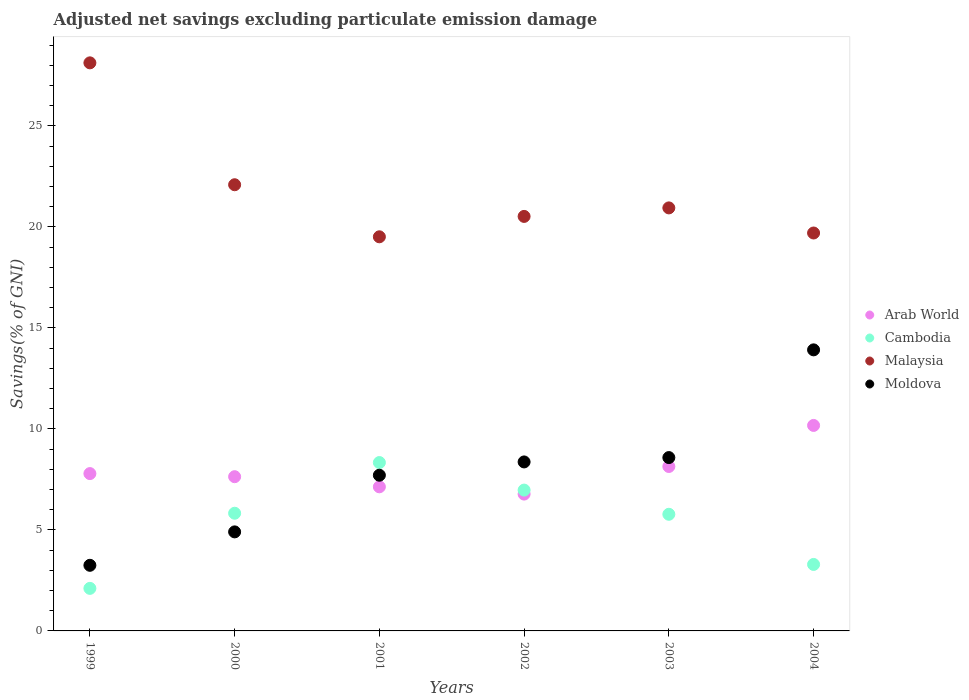How many different coloured dotlines are there?
Give a very brief answer. 4. Is the number of dotlines equal to the number of legend labels?
Your answer should be compact. Yes. What is the adjusted net savings in Malaysia in 2000?
Offer a terse response. 22.09. Across all years, what is the maximum adjusted net savings in Arab World?
Your answer should be compact. 10.17. Across all years, what is the minimum adjusted net savings in Cambodia?
Keep it short and to the point. 2.11. In which year was the adjusted net savings in Moldova maximum?
Make the answer very short. 2004. In which year was the adjusted net savings in Moldova minimum?
Make the answer very short. 1999. What is the total adjusted net savings in Moldova in the graph?
Offer a terse response. 46.72. What is the difference between the adjusted net savings in Cambodia in 2001 and that in 2004?
Ensure brevity in your answer.  5.04. What is the difference between the adjusted net savings in Arab World in 2004 and the adjusted net savings in Moldova in 2001?
Make the answer very short. 2.46. What is the average adjusted net savings in Malaysia per year?
Your response must be concise. 21.81. In the year 1999, what is the difference between the adjusted net savings in Arab World and adjusted net savings in Malaysia?
Provide a short and direct response. -20.33. In how many years, is the adjusted net savings in Malaysia greater than 1 %?
Give a very brief answer. 6. What is the ratio of the adjusted net savings in Arab World in 2001 to that in 2002?
Ensure brevity in your answer.  1.05. What is the difference between the highest and the second highest adjusted net savings in Cambodia?
Your response must be concise. 1.36. What is the difference between the highest and the lowest adjusted net savings in Arab World?
Make the answer very short. 3.4. In how many years, is the adjusted net savings in Cambodia greater than the average adjusted net savings in Cambodia taken over all years?
Your answer should be compact. 4. Is the sum of the adjusted net savings in Moldova in 2001 and 2003 greater than the maximum adjusted net savings in Arab World across all years?
Give a very brief answer. Yes. Is it the case that in every year, the sum of the adjusted net savings in Arab World and adjusted net savings in Malaysia  is greater than the sum of adjusted net savings in Moldova and adjusted net savings in Cambodia?
Ensure brevity in your answer.  No. Is it the case that in every year, the sum of the adjusted net savings in Cambodia and adjusted net savings in Arab World  is greater than the adjusted net savings in Moldova?
Ensure brevity in your answer.  No. Does the adjusted net savings in Moldova monotonically increase over the years?
Provide a short and direct response. Yes. Is the adjusted net savings in Moldova strictly greater than the adjusted net savings in Cambodia over the years?
Ensure brevity in your answer.  No. How many dotlines are there?
Make the answer very short. 4. How many years are there in the graph?
Your response must be concise. 6. Does the graph contain grids?
Keep it short and to the point. No. Where does the legend appear in the graph?
Offer a very short reply. Center right. How many legend labels are there?
Offer a very short reply. 4. What is the title of the graph?
Provide a short and direct response. Adjusted net savings excluding particulate emission damage. What is the label or title of the Y-axis?
Provide a short and direct response. Savings(% of GNI). What is the Savings(% of GNI) of Arab World in 1999?
Give a very brief answer. 7.79. What is the Savings(% of GNI) in Cambodia in 1999?
Your answer should be very brief. 2.11. What is the Savings(% of GNI) of Malaysia in 1999?
Make the answer very short. 28.12. What is the Savings(% of GNI) of Moldova in 1999?
Provide a short and direct response. 3.25. What is the Savings(% of GNI) of Arab World in 2000?
Provide a succinct answer. 7.63. What is the Savings(% of GNI) in Cambodia in 2000?
Provide a short and direct response. 5.82. What is the Savings(% of GNI) of Malaysia in 2000?
Your response must be concise. 22.09. What is the Savings(% of GNI) in Moldova in 2000?
Give a very brief answer. 4.9. What is the Savings(% of GNI) of Arab World in 2001?
Provide a short and direct response. 7.13. What is the Savings(% of GNI) of Cambodia in 2001?
Your response must be concise. 8.33. What is the Savings(% of GNI) in Malaysia in 2001?
Your response must be concise. 19.51. What is the Savings(% of GNI) in Moldova in 2001?
Provide a short and direct response. 7.71. What is the Savings(% of GNI) in Arab World in 2002?
Offer a terse response. 6.77. What is the Savings(% of GNI) of Cambodia in 2002?
Offer a very short reply. 6.97. What is the Savings(% of GNI) of Malaysia in 2002?
Ensure brevity in your answer.  20.52. What is the Savings(% of GNI) in Moldova in 2002?
Offer a very short reply. 8.37. What is the Savings(% of GNI) in Arab World in 2003?
Your answer should be compact. 8.14. What is the Savings(% of GNI) in Cambodia in 2003?
Your response must be concise. 5.77. What is the Savings(% of GNI) in Malaysia in 2003?
Make the answer very short. 20.94. What is the Savings(% of GNI) in Moldova in 2003?
Your response must be concise. 8.58. What is the Savings(% of GNI) in Arab World in 2004?
Offer a terse response. 10.17. What is the Savings(% of GNI) in Cambodia in 2004?
Offer a terse response. 3.29. What is the Savings(% of GNI) in Malaysia in 2004?
Your answer should be compact. 19.7. What is the Savings(% of GNI) of Moldova in 2004?
Keep it short and to the point. 13.91. Across all years, what is the maximum Savings(% of GNI) of Arab World?
Make the answer very short. 10.17. Across all years, what is the maximum Savings(% of GNI) of Cambodia?
Your answer should be very brief. 8.33. Across all years, what is the maximum Savings(% of GNI) of Malaysia?
Keep it short and to the point. 28.12. Across all years, what is the maximum Savings(% of GNI) of Moldova?
Provide a short and direct response. 13.91. Across all years, what is the minimum Savings(% of GNI) in Arab World?
Provide a succinct answer. 6.77. Across all years, what is the minimum Savings(% of GNI) in Cambodia?
Offer a terse response. 2.11. Across all years, what is the minimum Savings(% of GNI) in Malaysia?
Make the answer very short. 19.51. Across all years, what is the minimum Savings(% of GNI) of Moldova?
Provide a succinct answer. 3.25. What is the total Savings(% of GNI) in Arab World in the graph?
Give a very brief answer. 47.64. What is the total Savings(% of GNI) in Cambodia in the graph?
Your response must be concise. 32.3. What is the total Savings(% of GNI) of Malaysia in the graph?
Offer a very short reply. 130.87. What is the total Savings(% of GNI) in Moldova in the graph?
Offer a terse response. 46.72. What is the difference between the Savings(% of GNI) in Arab World in 1999 and that in 2000?
Provide a succinct answer. 0.15. What is the difference between the Savings(% of GNI) of Cambodia in 1999 and that in 2000?
Provide a succinct answer. -3.72. What is the difference between the Savings(% of GNI) in Malaysia in 1999 and that in 2000?
Give a very brief answer. 6.03. What is the difference between the Savings(% of GNI) in Moldova in 1999 and that in 2000?
Ensure brevity in your answer.  -1.65. What is the difference between the Savings(% of GNI) in Arab World in 1999 and that in 2001?
Offer a very short reply. 0.66. What is the difference between the Savings(% of GNI) in Cambodia in 1999 and that in 2001?
Offer a terse response. -6.23. What is the difference between the Savings(% of GNI) in Malaysia in 1999 and that in 2001?
Give a very brief answer. 8.61. What is the difference between the Savings(% of GNI) of Moldova in 1999 and that in 2001?
Your answer should be compact. -4.46. What is the difference between the Savings(% of GNI) of Arab World in 1999 and that in 2002?
Offer a terse response. 1.01. What is the difference between the Savings(% of GNI) in Cambodia in 1999 and that in 2002?
Your response must be concise. -4.86. What is the difference between the Savings(% of GNI) in Malaysia in 1999 and that in 2002?
Provide a succinct answer. 7.6. What is the difference between the Savings(% of GNI) in Moldova in 1999 and that in 2002?
Your response must be concise. -5.12. What is the difference between the Savings(% of GNI) of Arab World in 1999 and that in 2003?
Your answer should be very brief. -0.35. What is the difference between the Savings(% of GNI) in Cambodia in 1999 and that in 2003?
Give a very brief answer. -3.67. What is the difference between the Savings(% of GNI) of Malaysia in 1999 and that in 2003?
Keep it short and to the point. 7.18. What is the difference between the Savings(% of GNI) of Moldova in 1999 and that in 2003?
Make the answer very short. -5.33. What is the difference between the Savings(% of GNI) of Arab World in 1999 and that in 2004?
Your response must be concise. -2.38. What is the difference between the Savings(% of GNI) in Cambodia in 1999 and that in 2004?
Provide a short and direct response. -1.18. What is the difference between the Savings(% of GNI) in Malaysia in 1999 and that in 2004?
Your answer should be very brief. 8.42. What is the difference between the Savings(% of GNI) in Moldova in 1999 and that in 2004?
Your response must be concise. -10.66. What is the difference between the Savings(% of GNI) in Arab World in 2000 and that in 2001?
Offer a very short reply. 0.5. What is the difference between the Savings(% of GNI) in Cambodia in 2000 and that in 2001?
Offer a very short reply. -2.51. What is the difference between the Savings(% of GNI) in Malaysia in 2000 and that in 2001?
Provide a short and direct response. 2.58. What is the difference between the Savings(% of GNI) of Moldova in 2000 and that in 2001?
Keep it short and to the point. -2.8. What is the difference between the Savings(% of GNI) in Arab World in 2000 and that in 2002?
Provide a succinct answer. 0.86. What is the difference between the Savings(% of GNI) in Cambodia in 2000 and that in 2002?
Your answer should be compact. -1.15. What is the difference between the Savings(% of GNI) of Malaysia in 2000 and that in 2002?
Provide a short and direct response. 1.57. What is the difference between the Savings(% of GNI) of Moldova in 2000 and that in 2002?
Give a very brief answer. -3.46. What is the difference between the Savings(% of GNI) of Arab World in 2000 and that in 2003?
Offer a terse response. -0.5. What is the difference between the Savings(% of GNI) in Cambodia in 2000 and that in 2003?
Your answer should be compact. 0.05. What is the difference between the Savings(% of GNI) of Malaysia in 2000 and that in 2003?
Offer a very short reply. 1.15. What is the difference between the Savings(% of GNI) in Moldova in 2000 and that in 2003?
Your response must be concise. -3.68. What is the difference between the Savings(% of GNI) of Arab World in 2000 and that in 2004?
Give a very brief answer. -2.54. What is the difference between the Savings(% of GNI) in Cambodia in 2000 and that in 2004?
Provide a succinct answer. 2.53. What is the difference between the Savings(% of GNI) of Malaysia in 2000 and that in 2004?
Ensure brevity in your answer.  2.39. What is the difference between the Savings(% of GNI) of Moldova in 2000 and that in 2004?
Ensure brevity in your answer.  -9.01. What is the difference between the Savings(% of GNI) of Arab World in 2001 and that in 2002?
Keep it short and to the point. 0.36. What is the difference between the Savings(% of GNI) in Cambodia in 2001 and that in 2002?
Provide a succinct answer. 1.36. What is the difference between the Savings(% of GNI) of Malaysia in 2001 and that in 2002?
Provide a succinct answer. -1.01. What is the difference between the Savings(% of GNI) in Moldova in 2001 and that in 2002?
Make the answer very short. -0.66. What is the difference between the Savings(% of GNI) in Arab World in 2001 and that in 2003?
Offer a terse response. -1.01. What is the difference between the Savings(% of GNI) in Cambodia in 2001 and that in 2003?
Your answer should be compact. 2.56. What is the difference between the Savings(% of GNI) of Malaysia in 2001 and that in 2003?
Offer a terse response. -1.43. What is the difference between the Savings(% of GNI) of Moldova in 2001 and that in 2003?
Keep it short and to the point. -0.87. What is the difference between the Savings(% of GNI) in Arab World in 2001 and that in 2004?
Your answer should be very brief. -3.04. What is the difference between the Savings(% of GNI) in Cambodia in 2001 and that in 2004?
Keep it short and to the point. 5.04. What is the difference between the Savings(% of GNI) of Malaysia in 2001 and that in 2004?
Provide a short and direct response. -0.19. What is the difference between the Savings(% of GNI) of Moldova in 2001 and that in 2004?
Offer a terse response. -6.21. What is the difference between the Savings(% of GNI) in Arab World in 2002 and that in 2003?
Keep it short and to the point. -1.37. What is the difference between the Savings(% of GNI) of Cambodia in 2002 and that in 2003?
Your answer should be compact. 1.2. What is the difference between the Savings(% of GNI) in Malaysia in 2002 and that in 2003?
Provide a short and direct response. -0.42. What is the difference between the Savings(% of GNI) of Moldova in 2002 and that in 2003?
Provide a succinct answer. -0.22. What is the difference between the Savings(% of GNI) in Arab World in 2002 and that in 2004?
Offer a terse response. -3.4. What is the difference between the Savings(% of GNI) in Cambodia in 2002 and that in 2004?
Make the answer very short. 3.68. What is the difference between the Savings(% of GNI) of Malaysia in 2002 and that in 2004?
Ensure brevity in your answer.  0.82. What is the difference between the Savings(% of GNI) of Moldova in 2002 and that in 2004?
Make the answer very short. -5.55. What is the difference between the Savings(% of GNI) in Arab World in 2003 and that in 2004?
Ensure brevity in your answer.  -2.03. What is the difference between the Savings(% of GNI) of Cambodia in 2003 and that in 2004?
Provide a succinct answer. 2.48. What is the difference between the Savings(% of GNI) in Malaysia in 2003 and that in 2004?
Ensure brevity in your answer.  1.24. What is the difference between the Savings(% of GNI) of Moldova in 2003 and that in 2004?
Your response must be concise. -5.33. What is the difference between the Savings(% of GNI) of Arab World in 1999 and the Savings(% of GNI) of Cambodia in 2000?
Your answer should be compact. 1.96. What is the difference between the Savings(% of GNI) in Arab World in 1999 and the Savings(% of GNI) in Malaysia in 2000?
Your response must be concise. -14.3. What is the difference between the Savings(% of GNI) of Arab World in 1999 and the Savings(% of GNI) of Moldova in 2000?
Provide a short and direct response. 2.89. What is the difference between the Savings(% of GNI) of Cambodia in 1999 and the Savings(% of GNI) of Malaysia in 2000?
Keep it short and to the point. -19.98. What is the difference between the Savings(% of GNI) in Cambodia in 1999 and the Savings(% of GNI) in Moldova in 2000?
Provide a succinct answer. -2.8. What is the difference between the Savings(% of GNI) in Malaysia in 1999 and the Savings(% of GNI) in Moldova in 2000?
Give a very brief answer. 23.22. What is the difference between the Savings(% of GNI) of Arab World in 1999 and the Savings(% of GNI) of Cambodia in 2001?
Keep it short and to the point. -0.55. What is the difference between the Savings(% of GNI) of Arab World in 1999 and the Savings(% of GNI) of Malaysia in 2001?
Make the answer very short. -11.72. What is the difference between the Savings(% of GNI) of Arab World in 1999 and the Savings(% of GNI) of Moldova in 2001?
Offer a very short reply. 0.08. What is the difference between the Savings(% of GNI) of Cambodia in 1999 and the Savings(% of GNI) of Malaysia in 2001?
Make the answer very short. -17.4. What is the difference between the Savings(% of GNI) of Cambodia in 1999 and the Savings(% of GNI) of Moldova in 2001?
Offer a very short reply. -5.6. What is the difference between the Savings(% of GNI) in Malaysia in 1999 and the Savings(% of GNI) in Moldova in 2001?
Ensure brevity in your answer.  20.41. What is the difference between the Savings(% of GNI) of Arab World in 1999 and the Savings(% of GNI) of Cambodia in 2002?
Offer a very short reply. 0.82. What is the difference between the Savings(% of GNI) in Arab World in 1999 and the Savings(% of GNI) in Malaysia in 2002?
Provide a succinct answer. -12.73. What is the difference between the Savings(% of GNI) in Arab World in 1999 and the Savings(% of GNI) in Moldova in 2002?
Ensure brevity in your answer.  -0.58. What is the difference between the Savings(% of GNI) of Cambodia in 1999 and the Savings(% of GNI) of Malaysia in 2002?
Ensure brevity in your answer.  -18.41. What is the difference between the Savings(% of GNI) in Cambodia in 1999 and the Savings(% of GNI) in Moldova in 2002?
Make the answer very short. -6.26. What is the difference between the Savings(% of GNI) in Malaysia in 1999 and the Savings(% of GNI) in Moldova in 2002?
Make the answer very short. 19.75. What is the difference between the Savings(% of GNI) of Arab World in 1999 and the Savings(% of GNI) of Cambodia in 2003?
Your answer should be compact. 2.01. What is the difference between the Savings(% of GNI) of Arab World in 1999 and the Savings(% of GNI) of Malaysia in 2003?
Provide a succinct answer. -13.15. What is the difference between the Savings(% of GNI) in Arab World in 1999 and the Savings(% of GNI) in Moldova in 2003?
Give a very brief answer. -0.79. What is the difference between the Savings(% of GNI) of Cambodia in 1999 and the Savings(% of GNI) of Malaysia in 2003?
Offer a terse response. -18.83. What is the difference between the Savings(% of GNI) in Cambodia in 1999 and the Savings(% of GNI) in Moldova in 2003?
Ensure brevity in your answer.  -6.47. What is the difference between the Savings(% of GNI) of Malaysia in 1999 and the Savings(% of GNI) of Moldova in 2003?
Your response must be concise. 19.54. What is the difference between the Savings(% of GNI) of Arab World in 1999 and the Savings(% of GNI) of Cambodia in 2004?
Keep it short and to the point. 4.5. What is the difference between the Savings(% of GNI) in Arab World in 1999 and the Savings(% of GNI) in Malaysia in 2004?
Provide a succinct answer. -11.91. What is the difference between the Savings(% of GNI) in Arab World in 1999 and the Savings(% of GNI) in Moldova in 2004?
Ensure brevity in your answer.  -6.12. What is the difference between the Savings(% of GNI) in Cambodia in 1999 and the Savings(% of GNI) in Malaysia in 2004?
Ensure brevity in your answer.  -17.59. What is the difference between the Savings(% of GNI) of Cambodia in 1999 and the Savings(% of GNI) of Moldova in 2004?
Offer a terse response. -11.81. What is the difference between the Savings(% of GNI) in Malaysia in 1999 and the Savings(% of GNI) in Moldova in 2004?
Your response must be concise. 14.21. What is the difference between the Savings(% of GNI) in Arab World in 2000 and the Savings(% of GNI) in Cambodia in 2001?
Offer a terse response. -0.7. What is the difference between the Savings(% of GNI) of Arab World in 2000 and the Savings(% of GNI) of Malaysia in 2001?
Offer a very short reply. -11.87. What is the difference between the Savings(% of GNI) of Arab World in 2000 and the Savings(% of GNI) of Moldova in 2001?
Make the answer very short. -0.07. What is the difference between the Savings(% of GNI) of Cambodia in 2000 and the Savings(% of GNI) of Malaysia in 2001?
Your answer should be compact. -13.68. What is the difference between the Savings(% of GNI) in Cambodia in 2000 and the Savings(% of GNI) in Moldova in 2001?
Your answer should be very brief. -1.88. What is the difference between the Savings(% of GNI) of Malaysia in 2000 and the Savings(% of GNI) of Moldova in 2001?
Keep it short and to the point. 14.38. What is the difference between the Savings(% of GNI) in Arab World in 2000 and the Savings(% of GNI) in Cambodia in 2002?
Provide a short and direct response. 0.66. What is the difference between the Savings(% of GNI) in Arab World in 2000 and the Savings(% of GNI) in Malaysia in 2002?
Provide a short and direct response. -12.88. What is the difference between the Savings(% of GNI) in Arab World in 2000 and the Savings(% of GNI) in Moldova in 2002?
Provide a succinct answer. -0.73. What is the difference between the Savings(% of GNI) of Cambodia in 2000 and the Savings(% of GNI) of Malaysia in 2002?
Offer a very short reply. -14.69. What is the difference between the Savings(% of GNI) in Cambodia in 2000 and the Savings(% of GNI) in Moldova in 2002?
Make the answer very short. -2.54. What is the difference between the Savings(% of GNI) in Malaysia in 2000 and the Savings(% of GNI) in Moldova in 2002?
Provide a short and direct response. 13.72. What is the difference between the Savings(% of GNI) of Arab World in 2000 and the Savings(% of GNI) of Cambodia in 2003?
Keep it short and to the point. 1.86. What is the difference between the Savings(% of GNI) in Arab World in 2000 and the Savings(% of GNI) in Malaysia in 2003?
Ensure brevity in your answer.  -13.31. What is the difference between the Savings(% of GNI) of Arab World in 2000 and the Savings(% of GNI) of Moldova in 2003?
Your answer should be very brief. -0.95. What is the difference between the Savings(% of GNI) in Cambodia in 2000 and the Savings(% of GNI) in Malaysia in 2003?
Your answer should be very brief. -15.12. What is the difference between the Savings(% of GNI) in Cambodia in 2000 and the Savings(% of GNI) in Moldova in 2003?
Provide a succinct answer. -2.76. What is the difference between the Savings(% of GNI) of Malaysia in 2000 and the Savings(% of GNI) of Moldova in 2003?
Keep it short and to the point. 13.51. What is the difference between the Savings(% of GNI) of Arab World in 2000 and the Savings(% of GNI) of Cambodia in 2004?
Your answer should be compact. 4.34. What is the difference between the Savings(% of GNI) of Arab World in 2000 and the Savings(% of GNI) of Malaysia in 2004?
Offer a very short reply. -12.06. What is the difference between the Savings(% of GNI) in Arab World in 2000 and the Savings(% of GNI) in Moldova in 2004?
Provide a succinct answer. -6.28. What is the difference between the Savings(% of GNI) of Cambodia in 2000 and the Savings(% of GNI) of Malaysia in 2004?
Your answer should be compact. -13.87. What is the difference between the Savings(% of GNI) in Cambodia in 2000 and the Savings(% of GNI) in Moldova in 2004?
Give a very brief answer. -8.09. What is the difference between the Savings(% of GNI) of Malaysia in 2000 and the Savings(% of GNI) of Moldova in 2004?
Keep it short and to the point. 8.17. What is the difference between the Savings(% of GNI) of Arab World in 2001 and the Savings(% of GNI) of Cambodia in 2002?
Offer a very short reply. 0.16. What is the difference between the Savings(% of GNI) of Arab World in 2001 and the Savings(% of GNI) of Malaysia in 2002?
Provide a succinct answer. -13.39. What is the difference between the Savings(% of GNI) of Arab World in 2001 and the Savings(% of GNI) of Moldova in 2002?
Your response must be concise. -1.23. What is the difference between the Savings(% of GNI) of Cambodia in 2001 and the Savings(% of GNI) of Malaysia in 2002?
Make the answer very short. -12.18. What is the difference between the Savings(% of GNI) in Cambodia in 2001 and the Savings(% of GNI) in Moldova in 2002?
Offer a terse response. -0.03. What is the difference between the Savings(% of GNI) of Malaysia in 2001 and the Savings(% of GNI) of Moldova in 2002?
Your answer should be compact. 11.14. What is the difference between the Savings(% of GNI) in Arab World in 2001 and the Savings(% of GNI) in Cambodia in 2003?
Your answer should be very brief. 1.36. What is the difference between the Savings(% of GNI) in Arab World in 2001 and the Savings(% of GNI) in Malaysia in 2003?
Offer a very short reply. -13.81. What is the difference between the Savings(% of GNI) in Arab World in 2001 and the Savings(% of GNI) in Moldova in 2003?
Offer a very short reply. -1.45. What is the difference between the Savings(% of GNI) in Cambodia in 2001 and the Savings(% of GNI) in Malaysia in 2003?
Make the answer very short. -12.61. What is the difference between the Savings(% of GNI) in Cambodia in 2001 and the Savings(% of GNI) in Moldova in 2003?
Offer a very short reply. -0.25. What is the difference between the Savings(% of GNI) in Malaysia in 2001 and the Savings(% of GNI) in Moldova in 2003?
Make the answer very short. 10.93. What is the difference between the Savings(% of GNI) in Arab World in 2001 and the Savings(% of GNI) in Cambodia in 2004?
Offer a very short reply. 3.84. What is the difference between the Savings(% of GNI) in Arab World in 2001 and the Savings(% of GNI) in Malaysia in 2004?
Ensure brevity in your answer.  -12.56. What is the difference between the Savings(% of GNI) in Arab World in 2001 and the Savings(% of GNI) in Moldova in 2004?
Make the answer very short. -6.78. What is the difference between the Savings(% of GNI) in Cambodia in 2001 and the Savings(% of GNI) in Malaysia in 2004?
Give a very brief answer. -11.36. What is the difference between the Savings(% of GNI) in Cambodia in 2001 and the Savings(% of GNI) in Moldova in 2004?
Give a very brief answer. -5.58. What is the difference between the Savings(% of GNI) of Malaysia in 2001 and the Savings(% of GNI) of Moldova in 2004?
Ensure brevity in your answer.  5.6. What is the difference between the Savings(% of GNI) of Arab World in 2002 and the Savings(% of GNI) of Malaysia in 2003?
Keep it short and to the point. -14.17. What is the difference between the Savings(% of GNI) in Arab World in 2002 and the Savings(% of GNI) in Moldova in 2003?
Provide a succinct answer. -1.81. What is the difference between the Savings(% of GNI) in Cambodia in 2002 and the Savings(% of GNI) in Malaysia in 2003?
Provide a short and direct response. -13.97. What is the difference between the Savings(% of GNI) in Cambodia in 2002 and the Savings(% of GNI) in Moldova in 2003?
Keep it short and to the point. -1.61. What is the difference between the Savings(% of GNI) of Malaysia in 2002 and the Savings(% of GNI) of Moldova in 2003?
Your answer should be compact. 11.94. What is the difference between the Savings(% of GNI) in Arab World in 2002 and the Savings(% of GNI) in Cambodia in 2004?
Offer a very short reply. 3.48. What is the difference between the Savings(% of GNI) in Arab World in 2002 and the Savings(% of GNI) in Malaysia in 2004?
Provide a short and direct response. -12.92. What is the difference between the Savings(% of GNI) of Arab World in 2002 and the Savings(% of GNI) of Moldova in 2004?
Make the answer very short. -7.14. What is the difference between the Savings(% of GNI) in Cambodia in 2002 and the Savings(% of GNI) in Malaysia in 2004?
Provide a short and direct response. -12.73. What is the difference between the Savings(% of GNI) of Cambodia in 2002 and the Savings(% of GNI) of Moldova in 2004?
Offer a terse response. -6.94. What is the difference between the Savings(% of GNI) in Malaysia in 2002 and the Savings(% of GNI) in Moldova in 2004?
Your answer should be very brief. 6.61. What is the difference between the Savings(% of GNI) in Arab World in 2003 and the Savings(% of GNI) in Cambodia in 2004?
Give a very brief answer. 4.85. What is the difference between the Savings(% of GNI) of Arab World in 2003 and the Savings(% of GNI) of Malaysia in 2004?
Your answer should be compact. -11.56. What is the difference between the Savings(% of GNI) of Arab World in 2003 and the Savings(% of GNI) of Moldova in 2004?
Give a very brief answer. -5.77. What is the difference between the Savings(% of GNI) of Cambodia in 2003 and the Savings(% of GNI) of Malaysia in 2004?
Provide a succinct answer. -13.92. What is the difference between the Savings(% of GNI) of Cambodia in 2003 and the Savings(% of GNI) of Moldova in 2004?
Ensure brevity in your answer.  -8.14. What is the difference between the Savings(% of GNI) of Malaysia in 2003 and the Savings(% of GNI) of Moldova in 2004?
Ensure brevity in your answer.  7.03. What is the average Savings(% of GNI) in Arab World per year?
Offer a terse response. 7.94. What is the average Savings(% of GNI) of Cambodia per year?
Make the answer very short. 5.38. What is the average Savings(% of GNI) in Malaysia per year?
Offer a terse response. 21.81. What is the average Savings(% of GNI) of Moldova per year?
Keep it short and to the point. 7.79. In the year 1999, what is the difference between the Savings(% of GNI) of Arab World and Savings(% of GNI) of Cambodia?
Your answer should be compact. 5.68. In the year 1999, what is the difference between the Savings(% of GNI) of Arab World and Savings(% of GNI) of Malaysia?
Your answer should be very brief. -20.33. In the year 1999, what is the difference between the Savings(% of GNI) in Arab World and Savings(% of GNI) in Moldova?
Ensure brevity in your answer.  4.54. In the year 1999, what is the difference between the Savings(% of GNI) in Cambodia and Savings(% of GNI) in Malaysia?
Your answer should be very brief. -26.01. In the year 1999, what is the difference between the Savings(% of GNI) of Cambodia and Savings(% of GNI) of Moldova?
Make the answer very short. -1.14. In the year 1999, what is the difference between the Savings(% of GNI) in Malaysia and Savings(% of GNI) in Moldova?
Your answer should be very brief. 24.87. In the year 2000, what is the difference between the Savings(% of GNI) of Arab World and Savings(% of GNI) of Cambodia?
Your response must be concise. 1.81. In the year 2000, what is the difference between the Savings(% of GNI) of Arab World and Savings(% of GNI) of Malaysia?
Offer a terse response. -14.45. In the year 2000, what is the difference between the Savings(% of GNI) in Arab World and Savings(% of GNI) in Moldova?
Your answer should be compact. 2.73. In the year 2000, what is the difference between the Savings(% of GNI) of Cambodia and Savings(% of GNI) of Malaysia?
Offer a terse response. -16.26. In the year 2000, what is the difference between the Savings(% of GNI) in Cambodia and Savings(% of GNI) in Moldova?
Your response must be concise. 0.92. In the year 2000, what is the difference between the Savings(% of GNI) in Malaysia and Savings(% of GNI) in Moldova?
Your answer should be compact. 17.18. In the year 2001, what is the difference between the Savings(% of GNI) of Arab World and Savings(% of GNI) of Cambodia?
Your answer should be very brief. -1.2. In the year 2001, what is the difference between the Savings(% of GNI) of Arab World and Savings(% of GNI) of Malaysia?
Your answer should be very brief. -12.38. In the year 2001, what is the difference between the Savings(% of GNI) of Arab World and Savings(% of GNI) of Moldova?
Offer a very short reply. -0.57. In the year 2001, what is the difference between the Savings(% of GNI) in Cambodia and Savings(% of GNI) in Malaysia?
Your answer should be compact. -11.17. In the year 2001, what is the difference between the Savings(% of GNI) of Cambodia and Savings(% of GNI) of Moldova?
Keep it short and to the point. 0.63. In the year 2001, what is the difference between the Savings(% of GNI) in Malaysia and Savings(% of GNI) in Moldova?
Give a very brief answer. 11.8. In the year 2002, what is the difference between the Savings(% of GNI) in Arab World and Savings(% of GNI) in Cambodia?
Your answer should be compact. -0.2. In the year 2002, what is the difference between the Savings(% of GNI) in Arab World and Savings(% of GNI) in Malaysia?
Keep it short and to the point. -13.74. In the year 2002, what is the difference between the Savings(% of GNI) in Arab World and Savings(% of GNI) in Moldova?
Keep it short and to the point. -1.59. In the year 2002, what is the difference between the Savings(% of GNI) of Cambodia and Savings(% of GNI) of Malaysia?
Offer a terse response. -13.55. In the year 2002, what is the difference between the Savings(% of GNI) in Cambodia and Savings(% of GNI) in Moldova?
Your response must be concise. -1.39. In the year 2002, what is the difference between the Savings(% of GNI) of Malaysia and Savings(% of GNI) of Moldova?
Your answer should be very brief. 12.15. In the year 2003, what is the difference between the Savings(% of GNI) in Arab World and Savings(% of GNI) in Cambodia?
Make the answer very short. 2.37. In the year 2003, what is the difference between the Savings(% of GNI) of Arab World and Savings(% of GNI) of Malaysia?
Give a very brief answer. -12.8. In the year 2003, what is the difference between the Savings(% of GNI) of Arab World and Savings(% of GNI) of Moldova?
Offer a very short reply. -0.44. In the year 2003, what is the difference between the Savings(% of GNI) in Cambodia and Savings(% of GNI) in Malaysia?
Your answer should be compact. -15.17. In the year 2003, what is the difference between the Savings(% of GNI) in Cambodia and Savings(% of GNI) in Moldova?
Your answer should be compact. -2.81. In the year 2003, what is the difference between the Savings(% of GNI) of Malaysia and Savings(% of GNI) of Moldova?
Your answer should be compact. 12.36. In the year 2004, what is the difference between the Savings(% of GNI) of Arab World and Savings(% of GNI) of Cambodia?
Provide a short and direct response. 6.88. In the year 2004, what is the difference between the Savings(% of GNI) of Arab World and Savings(% of GNI) of Malaysia?
Offer a very short reply. -9.53. In the year 2004, what is the difference between the Savings(% of GNI) of Arab World and Savings(% of GNI) of Moldova?
Your answer should be very brief. -3.74. In the year 2004, what is the difference between the Savings(% of GNI) of Cambodia and Savings(% of GNI) of Malaysia?
Give a very brief answer. -16.41. In the year 2004, what is the difference between the Savings(% of GNI) in Cambodia and Savings(% of GNI) in Moldova?
Give a very brief answer. -10.62. In the year 2004, what is the difference between the Savings(% of GNI) of Malaysia and Savings(% of GNI) of Moldova?
Provide a short and direct response. 5.78. What is the ratio of the Savings(% of GNI) of Arab World in 1999 to that in 2000?
Make the answer very short. 1.02. What is the ratio of the Savings(% of GNI) in Cambodia in 1999 to that in 2000?
Offer a very short reply. 0.36. What is the ratio of the Savings(% of GNI) in Malaysia in 1999 to that in 2000?
Ensure brevity in your answer.  1.27. What is the ratio of the Savings(% of GNI) in Moldova in 1999 to that in 2000?
Your answer should be very brief. 0.66. What is the ratio of the Savings(% of GNI) in Arab World in 1999 to that in 2001?
Your answer should be compact. 1.09. What is the ratio of the Savings(% of GNI) of Cambodia in 1999 to that in 2001?
Ensure brevity in your answer.  0.25. What is the ratio of the Savings(% of GNI) of Malaysia in 1999 to that in 2001?
Give a very brief answer. 1.44. What is the ratio of the Savings(% of GNI) of Moldova in 1999 to that in 2001?
Provide a short and direct response. 0.42. What is the ratio of the Savings(% of GNI) of Arab World in 1999 to that in 2002?
Provide a short and direct response. 1.15. What is the ratio of the Savings(% of GNI) in Cambodia in 1999 to that in 2002?
Give a very brief answer. 0.3. What is the ratio of the Savings(% of GNI) in Malaysia in 1999 to that in 2002?
Your answer should be very brief. 1.37. What is the ratio of the Savings(% of GNI) of Moldova in 1999 to that in 2002?
Your answer should be very brief. 0.39. What is the ratio of the Savings(% of GNI) of Arab World in 1999 to that in 2003?
Make the answer very short. 0.96. What is the ratio of the Savings(% of GNI) in Cambodia in 1999 to that in 2003?
Your answer should be very brief. 0.36. What is the ratio of the Savings(% of GNI) in Malaysia in 1999 to that in 2003?
Your answer should be very brief. 1.34. What is the ratio of the Savings(% of GNI) of Moldova in 1999 to that in 2003?
Offer a terse response. 0.38. What is the ratio of the Savings(% of GNI) in Arab World in 1999 to that in 2004?
Provide a short and direct response. 0.77. What is the ratio of the Savings(% of GNI) of Cambodia in 1999 to that in 2004?
Keep it short and to the point. 0.64. What is the ratio of the Savings(% of GNI) in Malaysia in 1999 to that in 2004?
Your answer should be compact. 1.43. What is the ratio of the Savings(% of GNI) of Moldova in 1999 to that in 2004?
Keep it short and to the point. 0.23. What is the ratio of the Savings(% of GNI) in Arab World in 2000 to that in 2001?
Your answer should be very brief. 1.07. What is the ratio of the Savings(% of GNI) of Cambodia in 2000 to that in 2001?
Provide a short and direct response. 0.7. What is the ratio of the Savings(% of GNI) of Malaysia in 2000 to that in 2001?
Make the answer very short. 1.13. What is the ratio of the Savings(% of GNI) of Moldova in 2000 to that in 2001?
Provide a succinct answer. 0.64. What is the ratio of the Savings(% of GNI) in Arab World in 2000 to that in 2002?
Give a very brief answer. 1.13. What is the ratio of the Savings(% of GNI) in Cambodia in 2000 to that in 2002?
Your answer should be compact. 0.84. What is the ratio of the Savings(% of GNI) of Malaysia in 2000 to that in 2002?
Your answer should be very brief. 1.08. What is the ratio of the Savings(% of GNI) in Moldova in 2000 to that in 2002?
Your answer should be very brief. 0.59. What is the ratio of the Savings(% of GNI) in Arab World in 2000 to that in 2003?
Offer a very short reply. 0.94. What is the ratio of the Savings(% of GNI) in Cambodia in 2000 to that in 2003?
Your answer should be very brief. 1.01. What is the ratio of the Savings(% of GNI) in Malaysia in 2000 to that in 2003?
Offer a very short reply. 1.05. What is the ratio of the Savings(% of GNI) in Moldova in 2000 to that in 2003?
Offer a very short reply. 0.57. What is the ratio of the Savings(% of GNI) of Arab World in 2000 to that in 2004?
Your answer should be very brief. 0.75. What is the ratio of the Savings(% of GNI) of Cambodia in 2000 to that in 2004?
Offer a terse response. 1.77. What is the ratio of the Savings(% of GNI) of Malaysia in 2000 to that in 2004?
Offer a terse response. 1.12. What is the ratio of the Savings(% of GNI) of Moldova in 2000 to that in 2004?
Offer a very short reply. 0.35. What is the ratio of the Savings(% of GNI) of Arab World in 2001 to that in 2002?
Ensure brevity in your answer.  1.05. What is the ratio of the Savings(% of GNI) in Cambodia in 2001 to that in 2002?
Give a very brief answer. 1.2. What is the ratio of the Savings(% of GNI) in Malaysia in 2001 to that in 2002?
Provide a short and direct response. 0.95. What is the ratio of the Savings(% of GNI) of Moldova in 2001 to that in 2002?
Your response must be concise. 0.92. What is the ratio of the Savings(% of GNI) of Arab World in 2001 to that in 2003?
Provide a succinct answer. 0.88. What is the ratio of the Savings(% of GNI) of Cambodia in 2001 to that in 2003?
Provide a short and direct response. 1.44. What is the ratio of the Savings(% of GNI) of Malaysia in 2001 to that in 2003?
Your answer should be compact. 0.93. What is the ratio of the Savings(% of GNI) of Moldova in 2001 to that in 2003?
Your answer should be compact. 0.9. What is the ratio of the Savings(% of GNI) of Arab World in 2001 to that in 2004?
Your answer should be very brief. 0.7. What is the ratio of the Savings(% of GNI) in Cambodia in 2001 to that in 2004?
Provide a short and direct response. 2.53. What is the ratio of the Savings(% of GNI) of Malaysia in 2001 to that in 2004?
Provide a short and direct response. 0.99. What is the ratio of the Savings(% of GNI) in Moldova in 2001 to that in 2004?
Offer a terse response. 0.55. What is the ratio of the Savings(% of GNI) of Arab World in 2002 to that in 2003?
Offer a terse response. 0.83. What is the ratio of the Savings(% of GNI) in Cambodia in 2002 to that in 2003?
Make the answer very short. 1.21. What is the ratio of the Savings(% of GNI) of Malaysia in 2002 to that in 2003?
Provide a succinct answer. 0.98. What is the ratio of the Savings(% of GNI) of Moldova in 2002 to that in 2003?
Provide a short and direct response. 0.97. What is the ratio of the Savings(% of GNI) of Arab World in 2002 to that in 2004?
Your answer should be compact. 0.67. What is the ratio of the Savings(% of GNI) in Cambodia in 2002 to that in 2004?
Provide a succinct answer. 2.12. What is the ratio of the Savings(% of GNI) in Malaysia in 2002 to that in 2004?
Your answer should be compact. 1.04. What is the ratio of the Savings(% of GNI) in Moldova in 2002 to that in 2004?
Give a very brief answer. 0.6. What is the ratio of the Savings(% of GNI) in Arab World in 2003 to that in 2004?
Make the answer very short. 0.8. What is the ratio of the Savings(% of GNI) in Cambodia in 2003 to that in 2004?
Make the answer very short. 1.75. What is the ratio of the Savings(% of GNI) in Malaysia in 2003 to that in 2004?
Ensure brevity in your answer.  1.06. What is the ratio of the Savings(% of GNI) in Moldova in 2003 to that in 2004?
Make the answer very short. 0.62. What is the difference between the highest and the second highest Savings(% of GNI) of Arab World?
Offer a very short reply. 2.03. What is the difference between the highest and the second highest Savings(% of GNI) of Cambodia?
Your response must be concise. 1.36. What is the difference between the highest and the second highest Savings(% of GNI) in Malaysia?
Keep it short and to the point. 6.03. What is the difference between the highest and the second highest Savings(% of GNI) of Moldova?
Provide a short and direct response. 5.33. What is the difference between the highest and the lowest Savings(% of GNI) in Arab World?
Provide a short and direct response. 3.4. What is the difference between the highest and the lowest Savings(% of GNI) of Cambodia?
Give a very brief answer. 6.23. What is the difference between the highest and the lowest Savings(% of GNI) of Malaysia?
Your response must be concise. 8.61. What is the difference between the highest and the lowest Savings(% of GNI) in Moldova?
Offer a very short reply. 10.66. 